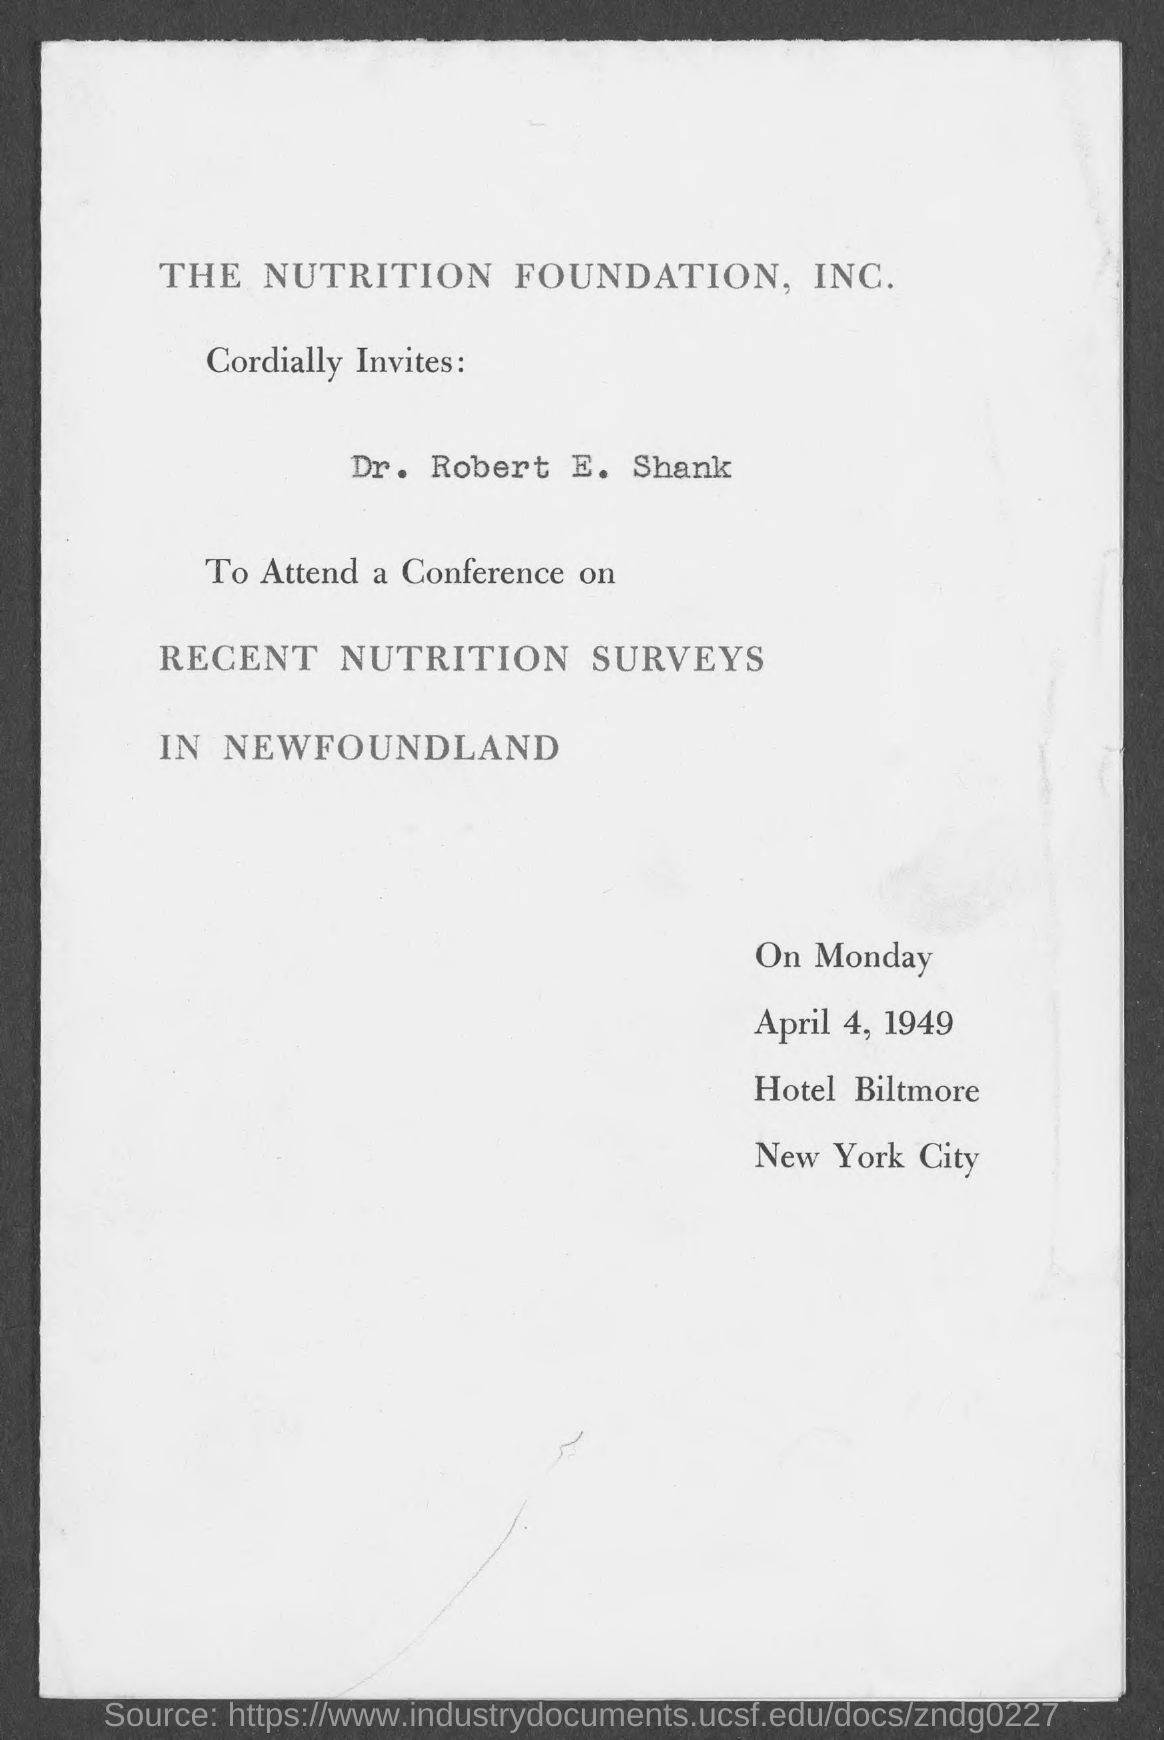What day of the week is mentioned in the document?
Your answer should be very brief. Monday. 